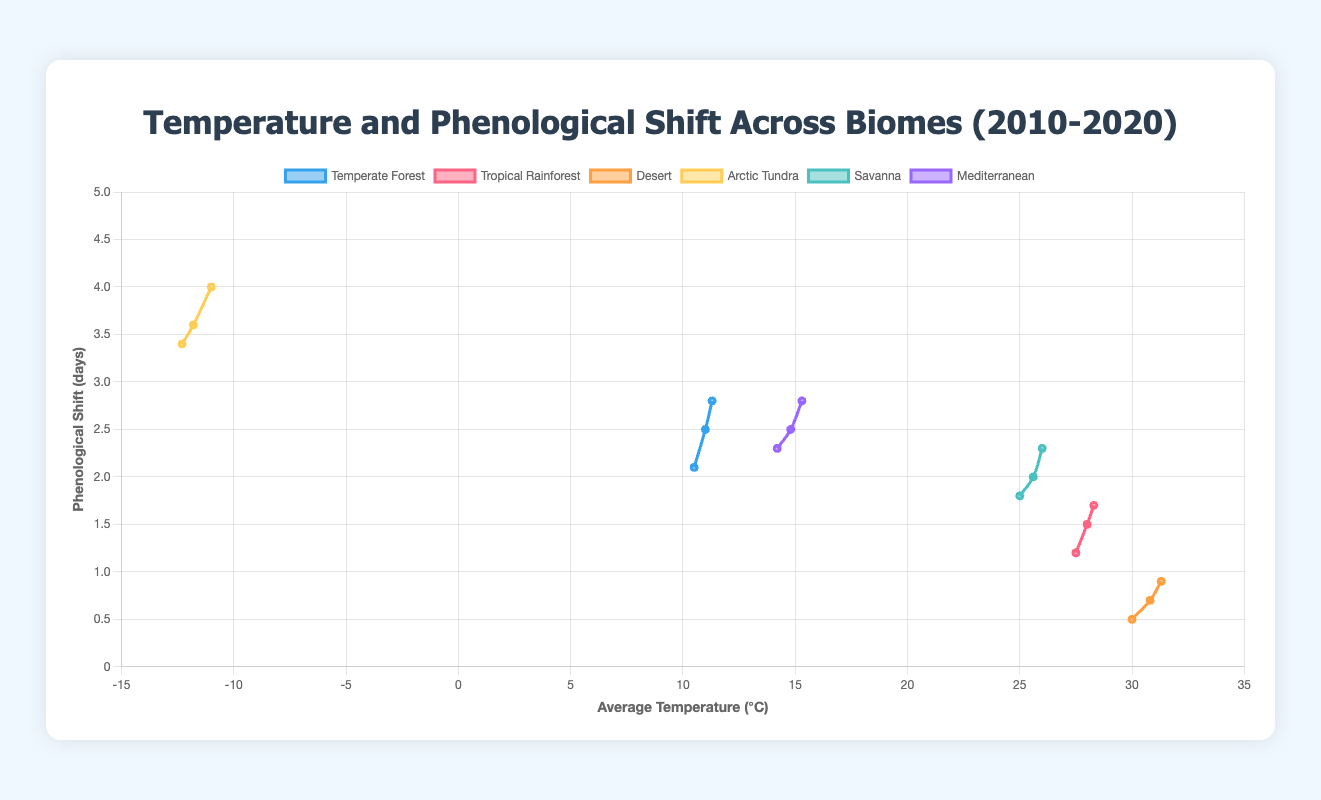What biome shows the greatest increase in average temperature from 2010 to 2020? By examining the data for each biome, we calculate the increase in average temperature over the years and identify the highest increase. For Temperate Forest, it increased from 10.5°C to 11.3°C (0.8°C). For Tropical Rainforest, it increased from 27.5°C to 28.3°C (0.8°C). For Desert, it increased from 30.0°C to 31.3°C (1.3°C). For Arctic Tundra, it increased from -12.3°C to -11.0°C (1.3°C). For Savanna, it increased from 25.0°C to 26.0°C (1.0°C). For Mediterranean, it increased from 14.2°C to 15.3°C (1.1°C). Both Desert and Arctic Tundra have the greatest increase of 1.3°C.
Answer: Desert, Arctic Tundra Which biome has the highest phenological shift in 2020? By referencing the phenological shifts for each biome in 2020 and comparing them, the highest shift is found in Arctic Tundra with 4.0 days.
Answer: Arctic Tundra How does the phenological shift in Sherwood Forest compare between 2010 and 2020? Looking at the data for Sherwood Forest in 2010 and 2020, the phenological shift increases from 2.1 days to 2.8 days. This shows an increase of 0.7 days.
Answer: Increased by 0.7 days Which biome has the least average temperature in 2020? Analyzing the 2020 data for all biomes, Barrow in Arctic Tundra records the least average temperature of -11.0°C.
Answer: Arctic Tundra Compute the average phenological shift for all biomes in 2015. Summing the phenological shifts in 2015 for all biomes: Temperate Forest (2.5), Tropical Rainforest (1.5), Desert (0.7), Arctic Tundra (3.6), Savanna (2.0), Mediterranean (2.5). The total is 12.8, averaging over 6 biomes: 12.8 / 6 = 2.13 days.
Answer: 2.13 days What is the difference in phenological shift between the Mediterranean and Savanna biomes in 2020? In 2020, the phenological shift in the Mediterranean biome is 2.8 days, while in the Savanna biome it is 2.3 days. The difference is 2.8 - 2.3 = 0.5 days.
Answer: 0.5 days Identify the biome with the smallest change in average temperature from 2010 to 2020. Calculating the change for each biome, the smallest change is for Tropical Rainforest from 27.5°C to 28.3°C, a difference of 0.8°C.
Answer: Tropical Rainforest Visualize the phenological shifts for the biomes with the highest and lowest average temperatures in 2020. How do they compare? The biomes with the highest and lowest average temperatures in 2020 are Desert (31.3°C) and Arctic Tundra (-11.0°C), respectively. The phenological shifts for these biomes are 0.9 days (Desert) and 4.0 days (Arctic Tundra), indicating Arctic Tundra has a significantly higher shift.
Answer: Arctic Tundra shift > Desert shift 